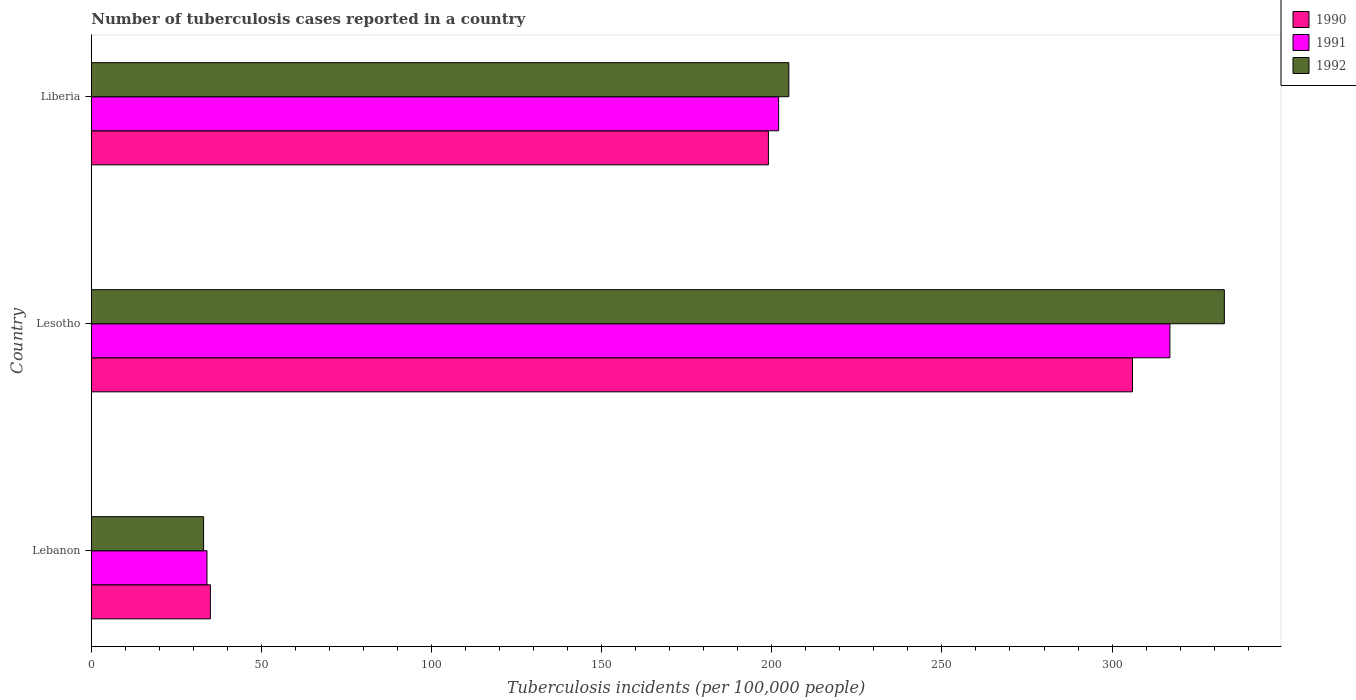How many different coloured bars are there?
Make the answer very short. 3. Are the number of bars on each tick of the Y-axis equal?
Keep it short and to the point. Yes. How many bars are there on the 1st tick from the bottom?
Offer a very short reply. 3. What is the label of the 2nd group of bars from the top?
Keep it short and to the point. Lesotho. Across all countries, what is the maximum number of tuberculosis cases reported in in 1990?
Your response must be concise. 306. Across all countries, what is the minimum number of tuberculosis cases reported in in 1991?
Your response must be concise. 34. In which country was the number of tuberculosis cases reported in in 1990 maximum?
Provide a short and direct response. Lesotho. In which country was the number of tuberculosis cases reported in in 1990 minimum?
Provide a succinct answer. Lebanon. What is the total number of tuberculosis cases reported in in 1991 in the graph?
Your response must be concise. 553. What is the difference between the number of tuberculosis cases reported in in 1992 in Lebanon and that in Lesotho?
Offer a terse response. -300. What is the difference between the number of tuberculosis cases reported in in 1991 in Lesotho and the number of tuberculosis cases reported in in 1992 in Lebanon?
Provide a succinct answer. 284. What is the average number of tuberculosis cases reported in in 1992 per country?
Make the answer very short. 190.33. In how many countries, is the number of tuberculosis cases reported in in 1990 greater than 220 ?
Keep it short and to the point. 1. What is the ratio of the number of tuberculosis cases reported in in 1990 in Lesotho to that in Liberia?
Your response must be concise. 1.54. What is the difference between the highest and the second highest number of tuberculosis cases reported in in 1990?
Your answer should be very brief. 107. What is the difference between the highest and the lowest number of tuberculosis cases reported in in 1990?
Make the answer very short. 271. In how many countries, is the number of tuberculosis cases reported in in 1992 greater than the average number of tuberculosis cases reported in in 1992 taken over all countries?
Keep it short and to the point. 2. Is the sum of the number of tuberculosis cases reported in in 1990 in Lebanon and Liberia greater than the maximum number of tuberculosis cases reported in in 1992 across all countries?
Provide a succinct answer. No. What does the 1st bar from the bottom in Lebanon represents?
Keep it short and to the point. 1990. Is it the case that in every country, the sum of the number of tuberculosis cases reported in in 1992 and number of tuberculosis cases reported in in 1990 is greater than the number of tuberculosis cases reported in in 1991?
Give a very brief answer. Yes. Are the values on the major ticks of X-axis written in scientific E-notation?
Give a very brief answer. No. Does the graph contain any zero values?
Make the answer very short. No. Does the graph contain grids?
Your answer should be very brief. No. Where does the legend appear in the graph?
Offer a very short reply. Top right. How many legend labels are there?
Give a very brief answer. 3. How are the legend labels stacked?
Your response must be concise. Vertical. What is the title of the graph?
Give a very brief answer. Number of tuberculosis cases reported in a country. What is the label or title of the X-axis?
Your response must be concise. Tuberculosis incidents (per 100,0 people). What is the Tuberculosis incidents (per 100,000 people) of 1990 in Lebanon?
Give a very brief answer. 35. What is the Tuberculosis incidents (per 100,000 people) in 1991 in Lebanon?
Your response must be concise. 34. What is the Tuberculosis incidents (per 100,000 people) of 1990 in Lesotho?
Provide a succinct answer. 306. What is the Tuberculosis incidents (per 100,000 people) in 1991 in Lesotho?
Ensure brevity in your answer.  317. What is the Tuberculosis incidents (per 100,000 people) in 1992 in Lesotho?
Provide a succinct answer. 333. What is the Tuberculosis incidents (per 100,000 people) in 1990 in Liberia?
Keep it short and to the point. 199. What is the Tuberculosis incidents (per 100,000 people) in 1991 in Liberia?
Offer a very short reply. 202. What is the Tuberculosis incidents (per 100,000 people) of 1992 in Liberia?
Keep it short and to the point. 205. Across all countries, what is the maximum Tuberculosis incidents (per 100,000 people) in 1990?
Ensure brevity in your answer.  306. Across all countries, what is the maximum Tuberculosis incidents (per 100,000 people) of 1991?
Offer a terse response. 317. Across all countries, what is the maximum Tuberculosis incidents (per 100,000 people) in 1992?
Ensure brevity in your answer.  333. Across all countries, what is the minimum Tuberculosis incidents (per 100,000 people) in 1992?
Your answer should be compact. 33. What is the total Tuberculosis incidents (per 100,000 people) of 1990 in the graph?
Your answer should be very brief. 540. What is the total Tuberculosis incidents (per 100,000 people) in 1991 in the graph?
Offer a terse response. 553. What is the total Tuberculosis incidents (per 100,000 people) of 1992 in the graph?
Provide a short and direct response. 571. What is the difference between the Tuberculosis incidents (per 100,000 people) of 1990 in Lebanon and that in Lesotho?
Keep it short and to the point. -271. What is the difference between the Tuberculosis incidents (per 100,000 people) in 1991 in Lebanon and that in Lesotho?
Provide a succinct answer. -283. What is the difference between the Tuberculosis incidents (per 100,000 people) of 1992 in Lebanon and that in Lesotho?
Your answer should be very brief. -300. What is the difference between the Tuberculosis incidents (per 100,000 people) in 1990 in Lebanon and that in Liberia?
Make the answer very short. -164. What is the difference between the Tuberculosis incidents (per 100,000 people) of 1991 in Lebanon and that in Liberia?
Keep it short and to the point. -168. What is the difference between the Tuberculosis incidents (per 100,000 people) in 1992 in Lebanon and that in Liberia?
Provide a short and direct response. -172. What is the difference between the Tuberculosis incidents (per 100,000 people) in 1990 in Lesotho and that in Liberia?
Your answer should be very brief. 107. What is the difference between the Tuberculosis incidents (per 100,000 people) of 1991 in Lesotho and that in Liberia?
Provide a succinct answer. 115. What is the difference between the Tuberculosis incidents (per 100,000 people) in 1992 in Lesotho and that in Liberia?
Your answer should be very brief. 128. What is the difference between the Tuberculosis incidents (per 100,000 people) in 1990 in Lebanon and the Tuberculosis incidents (per 100,000 people) in 1991 in Lesotho?
Make the answer very short. -282. What is the difference between the Tuberculosis incidents (per 100,000 people) of 1990 in Lebanon and the Tuberculosis incidents (per 100,000 people) of 1992 in Lesotho?
Keep it short and to the point. -298. What is the difference between the Tuberculosis incidents (per 100,000 people) of 1991 in Lebanon and the Tuberculosis incidents (per 100,000 people) of 1992 in Lesotho?
Provide a short and direct response. -299. What is the difference between the Tuberculosis incidents (per 100,000 people) in 1990 in Lebanon and the Tuberculosis incidents (per 100,000 people) in 1991 in Liberia?
Offer a very short reply. -167. What is the difference between the Tuberculosis incidents (per 100,000 people) in 1990 in Lebanon and the Tuberculosis incidents (per 100,000 people) in 1992 in Liberia?
Offer a very short reply. -170. What is the difference between the Tuberculosis incidents (per 100,000 people) in 1991 in Lebanon and the Tuberculosis incidents (per 100,000 people) in 1992 in Liberia?
Ensure brevity in your answer.  -171. What is the difference between the Tuberculosis incidents (per 100,000 people) in 1990 in Lesotho and the Tuberculosis incidents (per 100,000 people) in 1991 in Liberia?
Provide a succinct answer. 104. What is the difference between the Tuberculosis incidents (per 100,000 people) in 1990 in Lesotho and the Tuberculosis incidents (per 100,000 people) in 1992 in Liberia?
Keep it short and to the point. 101. What is the difference between the Tuberculosis incidents (per 100,000 people) in 1991 in Lesotho and the Tuberculosis incidents (per 100,000 people) in 1992 in Liberia?
Offer a very short reply. 112. What is the average Tuberculosis incidents (per 100,000 people) in 1990 per country?
Give a very brief answer. 180. What is the average Tuberculosis incidents (per 100,000 people) of 1991 per country?
Offer a very short reply. 184.33. What is the average Tuberculosis incidents (per 100,000 people) in 1992 per country?
Your answer should be very brief. 190.33. What is the difference between the Tuberculosis incidents (per 100,000 people) of 1990 and Tuberculosis incidents (per 100,000 people) of 1991 in Lebanon?
Your answer should be compact. 1. What is the difference between the Tuberculosis incidents (per 100,000 people) in 1991 and Tuberculosis incidents (per 100,000 people) in 1992 in Lebanon?
Offer a very short reply. 1. What is the difference between the Tuberculosis incidents (per 100,000 people) in 1990 and Tuberculosis incidents (per 100,000 people) in 1991 in Lesotho?
Offer a very short reply. -11. What is the difference between the Tuberculosis incidents (per 100,000 people) of 1990 and Tuberculosis incidents (per 100,000 people) of 1992 in Lesotho?
Your response must be concise. -27. What is the difference between the Tuberculosis incidents (per 100,000 people) in 1990 and Tuberculosis incidents (per 100,000 people) in 1991 in Liberia?
Give a very brief answer. -3. What is the ratio of the Tuberculosis incidents (per 100,000 people) of 1990 in Lebanon to that in Lesotho?
Provide a short and direct response. 0.11. What is the ratio of the Tuberculosis incidents (per 100,000 people) in 1991 in Lebanon to that in Lesotho?
Make the answer very short. 0.11. What is the ratio of the Tuberculosis incidents (per 100,000 people) in 1992 in Lebanon to that in Lesotho?
Offer a very short reply. 0.1. What is the ratio of the Tuberculosis incidents (per 100,000 people) of 1990 in Lebanon to that in Liberia?
Provide a succinct answer. 0.18. What is the ratio of the Tuberculosis incidents (per 100,000 people) in 1991 in Lebanon to that in Liberia?
Keep it short and to the point. 0.17. What is the ratio of the Tuberculosis incidents (per 100,000 people) of 1992 in Lebanon to that in Liberia?
Provide a succinct answer. 0.16. What is the ratio of the Tuberculosis incidents (per 100,000 people) in 1990 in Lesotho to that in Liberia?
Offer a terse response. 1.54. What is the ratio of the Tuberculosis incidents (per 100,000 people) in 1991 in Lesotho to that in Liberia?
Make the answer very short. 1.57. What is the ratio of the Tuberculosis incidents (per 100,000 people) of 1992 in Lesotho to that in Liberia?
Give a very brief answer. 1.62. What is the difference between the highest and the second highest Tuberculosis incidents (per 100,000 people) in 1990?
Give a very brief answer. 107. What is the difference between the highest and the second highest Tuberculosis incidents (per 100,000 people) in 1991?
Ensure brevity in your answer.  115. What is the difference between the highest and the second highest Tuberculosis incidents (per 100,000 people) in 1992?
Make the answer very short. 128. What is the difference between the highest and the lowest Tuberculosis incidents (per 100,000 people) of 1990?
Your answer should be very brief. 271. What is the difference between the highest and the lowest Tuberculosis incidents (per 100,000 people) of 1991?
Keep it short and to the point. 283. What is the difference between the highest and the lowest Tuberculosis incidents (per 100,000 people) in 1992?
Your answer should be very brief. 300. 